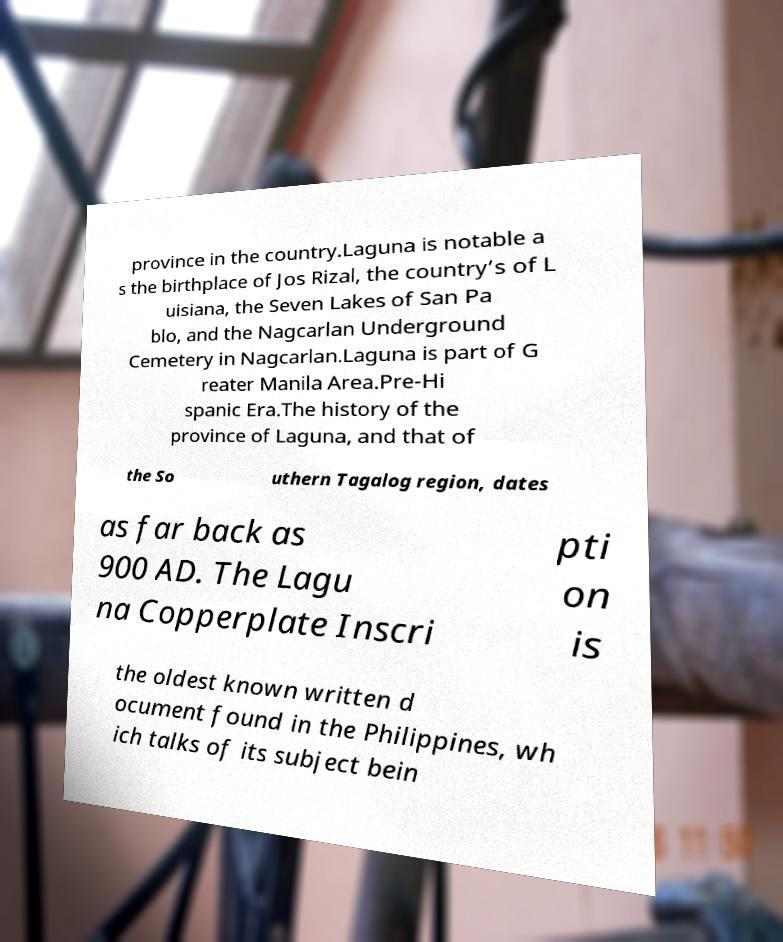There's text embedded in this image that I need extracted. Can you transcribe it verbatim? province in the country.Laguna is notable a s the birthplace of Jos Rizal, the country’s of L uisiana, the Seven Lakes of San Pa blo, and the Nagcarlan Underground Cemetery in Nagcarlan.Laguna is part of G reater Manila Area.Pre-Hi spanic Era.The history of the province of Laguna, and that of the So uthern Tagalog region, dates as far back as 900 AD. The Lagu na Copperplate Inscri pti on is the oldest known written d ocument found in the Philippines, wh ich talks of its subject bein 